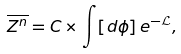<formula> <loc_0><loc_0><loc_500><loc_500>\overline { Z ^ { n } } = C \times \int [ d \phi ] \, e ^ { - \mathcal { L } } ,</formula> 